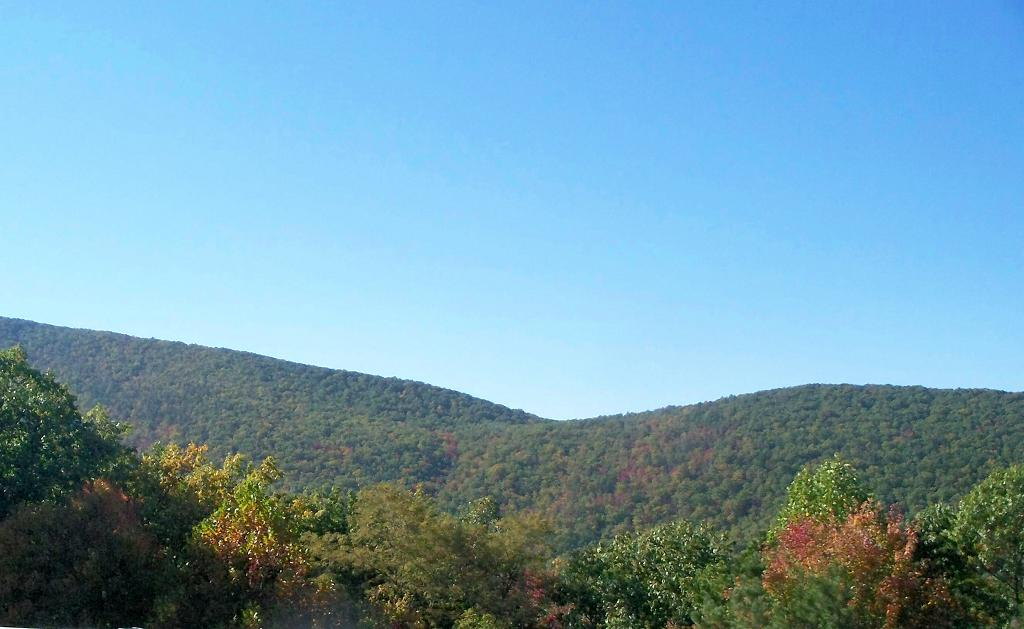What type of natural features can be seen in the image? There are trees and mountains in the image. What is visible in the background of the image? The sky is visible in the background of the image. What color is the sky in the image? The sky is blue in the image. How many fingers can be seen pointing at the toy in the image? There is no toy or fingers present in the image. What type of toy can be seen falling from the mountain in the image? There is no toy or indication of anything falling from the mountain in the image. 